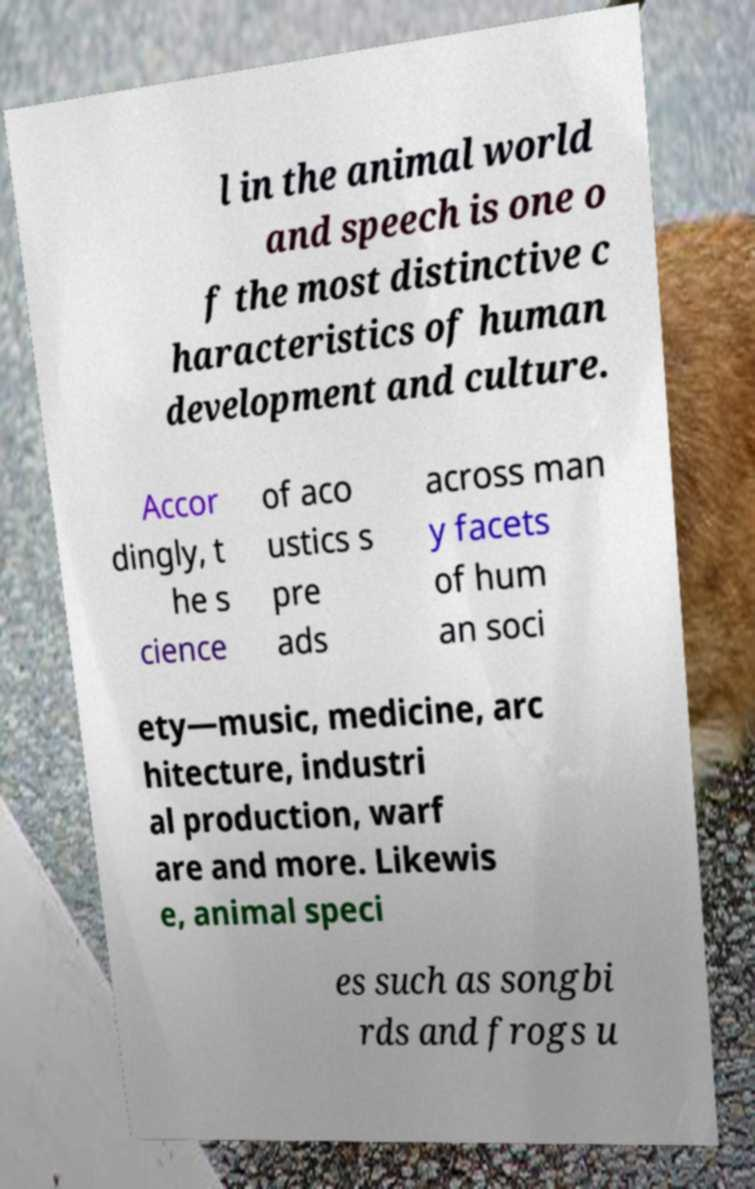Please identify and transcribe the text found in this image. l in the animal world and speech is one o f the most distinctive c haracteristics of human development and culture. Accor dingly, t he s cience of aco ustics s pre ads across man y facets of hum an soci ety—music, medicine, arc hitecture, industri al production, warf are and more. Likewis e, animal speci es such as songbi rds and frogs u 